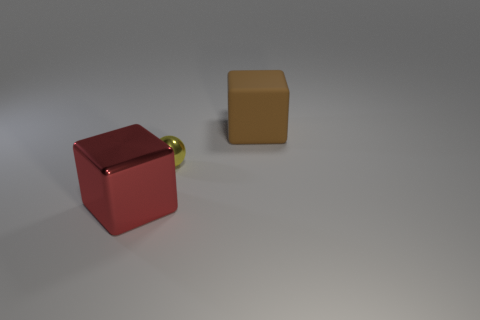Is the material of the small yellow ball that is in front of the brown cube the same as the cube that is right of the yellow ball?
Offer a terse response. No. There is a brown rubber thing that is on the right side of the yellow metal ball; does it have the same size as the ball?
Provide a short and direct response. No. The large red metal object has what shape?
Provide a succinct answer. Cube. How many things are either blocks that are right of the large shiny object or red shiny blocks?
Your answer should be compact. 2. There is a yellow thing that is the same material as the red thing; what size is it?
Make the answer very short. Small. Is the number of red shiny things to the left of the yellow metallic thing greater than the number of large cyan rubber balls?
Keep it short and to the point. Yes. There is a large brown thing; does it have the same shape as the big thing left of the big brown thing?
Provide a short and direct response. Yes. How many big objects are blue matte cylinders or red shiny blocks?
Make the answer very short. 1. What is the color of the metallic thing on the right side of the large thing in front of the big matte object?
Your answer should be compact. Yellow. Is the material of the big brown block the same as the big object that is in front of the small object?
Your answer should be very brief. No. 